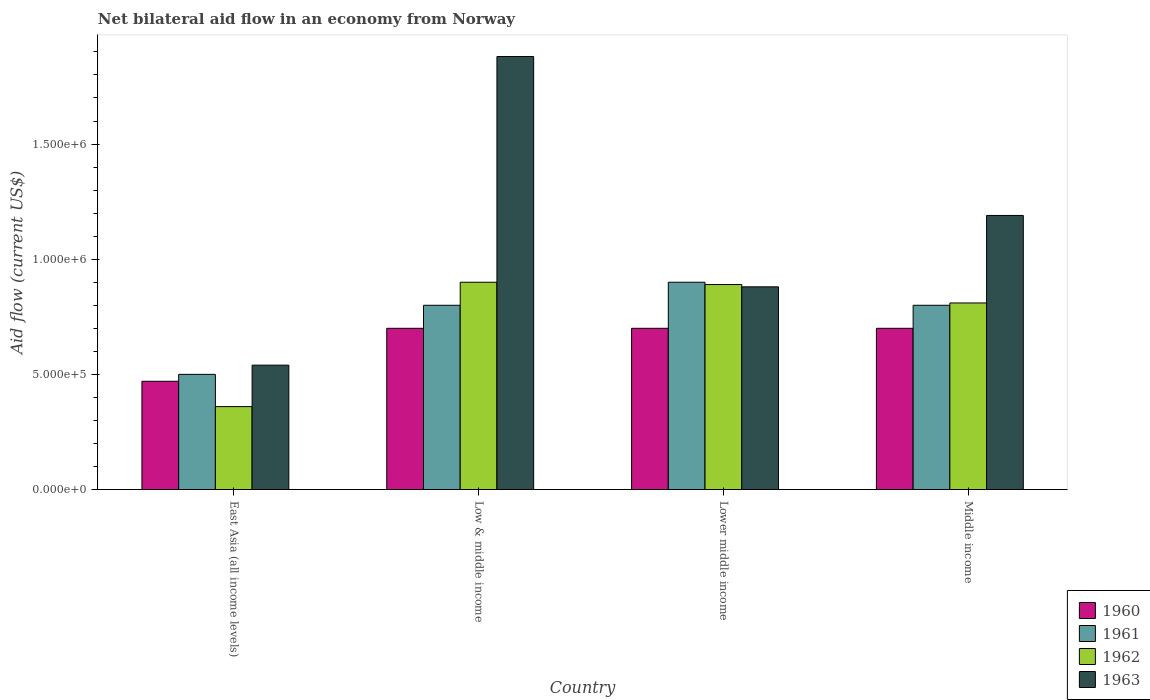How many different coloured bars are there?
Offer a terse response. 4. Are the number of bars on each tick of the X-axis equal?
Offer a terse response. Yes. How many bars are there on the 2nd tick from the left?
Your answer should be very brief. 4. What is the label of the 1st group of bars from the left?
Your answer should be compact. East Asia (all income levels). In how many cases, is the number of bars for a given country not equal to the number of legend labels?
Your response must be concise. 0. Across all countries, what is the maximum net bilateral aid flow in 1962?
Keep it short and to the point. 9.00e+05. In which country was the net bilateral aid flow in 1961 maximum?
Provide a succinct answer. Lower middle income. In which country was the net bilateral aid flow in 1962 minimum?
Offer a very short reply. East Asia (all income levels). What is the difference between the net bilateral aid flow in 1960 in East Asia (all income levels) and that in Middle income?
Ensure brevity in your answer.  -2.30e+05. What is the average net bilateral aid flow in 1960 per country?
Offer a very short reply. 6.42e+05. What is the ratio of the net bilateral aid flow in 1960 in Lower middle income to that in Middle income?
Offer a very short reply. 1. Is the net bilateral aid flow in 1961 in Low & middle income less than that in Lower middle income?
Offer a terse response. Yes. What is the difference between the highest and the second highest net bilateral aid flow in 1962?
Provide a short and direct response. 9.00e+04. Is it the case that in every country, the sum of the net bilateral aid flow in 1960 and net bilateral aid flow in 1963 is greater than the net bilateral aid flow in 1961?
Make the answer very short. Yes. Are all the bars in the graph horizontal?
Ensure brevity in your answer.  No. Are the values on the major ticks of Y-axis written in scientific E-notation?
Provide a short and direct response. Yes. Does the graph contain grids?
Offer a terse response. No. How many legend labels are there?
Provide a succinct answer. 4. What is the title of the graph?
Ensure brevity in your answer.  Net bilateral aid flow in an economy from Norway. Does "1985" appear as one of the legend labels in the graph?
Offer a very short reply. No. What is the label or title of the X-axis?
Your response must be concise. Country. What is the Aid flow (current US$) of 1963 in East Asia (all income levels)?
Provide a short and direct response. 5.40e+05. What is the Aid flow (current US$) in 1960 in Low & middle income?
Offer a very short reply. 7.00e+05. What is the Aid flow (current US$) of 1961 in Low & middle income?
Ensure brevity in your answer.  8.00e+05. What is the Aid flow (current US$) of 1963 in Low & middle income?
Ensure brevity in your answer.  1.88e+06. What is the Aid flow (current US$) of 1962 in Lower middle income?
Your answer should be compact. 8.90e+05. What is the Aid flow (current US$) in 1963 in Lower middle income?
Ensure brevity in your answer.  8.80e+05. What is the Aid flow (current US$) in 1960 in Middle income?
Make the answer very short. 7.00e+05. What is the Aid flow (current US$) in 1962 in Middle income?
Your answer should be compact. 8.10e+05. What is the Aid flow (current US$) in 1963 in Middle income?
Your response must be concise. 1.19e+06. Across all countries, what is the maximum Aid flow (current US$) in 1960?
Keep it short and to the point. 7.00e+05. Across all countries, what is the maximum Aid flow (current US$) in 1963?
Make the answer very short. 1.88e+06. Across all countries, what is the minimum Aid flow (current US$) of 1960?
Keep it short and to the point. 4.70e+05. Across all countries, what is the minimum Aid flow (current US$) of 1961?
Make the answer very short. 5.00e+05. Across all countries, what is the minimum Aid flow (current US$) in 1963?
Offer a terse response. 5.40e+05. What is the total Aid flow (current US$) of 1960 in the graph?
Make the answer very short. 2.57e+06. What is the total Aid flow (current US$) of 1962 in the graph?
Keep it short and to the point. 2.96e+06. What is the total Aid flow (current US$) of 1963 in the graph?
Offer a very short reply. 4.49e+06. What is the difference between the Aid flow (current US$) in 1961 in East Asia (all income levels) and that in Low & middle income?
Ensure brevity in your answer.  -3.00e+05. What is the difference between the Aid flow (current US$) of 1962 in East Asia (all income levels) and that in Low & middle income?
Offer a terse response. -5.40e+05. What is the difference between the Aid flow (current US$) of 1963 in East Asia (all income levels) and that in Low & middle income?
Keep it short and to the point. -1.34e+06. What is the difference between the Aid flow (current US$) in 1960 in East Asia (all income levels) and that in Lower middle income?
Ensure brevity in your answer.  -2.30e+05. What is the difference between the Aid flow (current US$) in 1961 in East Asia (all income levels) and that in Lower middle income?
Keep it short and to the point. -4.00e+05. What is the difference between the Aid flow (current US$) of 1962 in East Asia (all income levels) and that in Lower middle income?
Your response must be concise. -5.30e+05. What is the difference between the Aid flow (current US$) in 1960 in East Asia (all income levels) and that in Middle income?
Provide a succinct answer. -2.30e+05. What is the difference between the Aid flow (current US$) in 1962 in East Asia (all income levels) and that in Middle income?
Your response must be concise. -4.50e+05. What is the difference between the Aid flow (current US$) of 1963 in East Asia (all income levels) and that in Middle income?
Ensure brevity in your answer.  -6.50e+05. What is the difference between the Aid flow (current US$) in 1960 in Low & middle income and that in Lower middle income?
Your answer should be very brief. 0. What is the difference between the Aid flow (current US$) in 1961 in Low & middle income and that in Lower middle income?
Your response must be concise. -1.00e+05. What is the difference between the Aid flow (current US$) in 1962 in Low & middle income and that in Lower middle income?
Provide a succinct answer. 10000. What is the difference between the Aid flow (current US$) in 1963 in Low & middle income and that in Lower middle income?
Offer a terse response. 1.00e+06. What is the difference between the Aid flow (current US$) of 1963 in Low & middle income and that in Middle income?
Provide a short and direct response. 6.90e+05. What is the difference between the Aid flow (current US$) of 1960 in Lower middle income and that in Middle income?
Your response must be concise. 0. What is the difference between the Aid flow (current US$) of 1961 in Lower middle income and that in Middle income?
Your response must be concise. 1.00e+05. What is the difference between the Aid flow (current US$) in 1963 in Lower middle income and that in Middle income?
Ensure brevity in your answer.  -3.10e+05. What is the difference between the Aid flow (current US$) in 1960 in East Asia (all income levels) and the Aid flow (current US$) in 1961 in Low & middle income?
Offer a very short reply. -3.30e+05. What is the difference between the Aid flow (current US$) of 1960 in East Asia (all income levels) and the Aid flow (current US$) of 1962 in Low & middle income?
Provide a succinct answer. -4.30e+05. What is the difference between the Aid flow (current US$) of 1960 in East Asia (all income levels) and the Aid flow (current US$) of 1963 in Low & middle income?
Offer a terse response. -1.41e+06. What is the difference between the Aid flow (current US$) in 1961 in East Asia (all income levels) and the Aid flow (current US$) in 1962 in Low & middle income?
Keep it short and to the point. -4.00e+05. What is the difference between the Aid flow (current US$) in 1961 in East Asia (all income levels) and the Aid flow (current US$) in 1963 in Low & middle income?
Keep it short and to the point. -1.38e+06. What is the difference between the Aid flow (current US$) in 1962 in East Asia (all income levels) and the Aid flow (current US$) in 1963 in Low & middle income?
Make the answer very short. -1.52e+06. What is the difference between the Aid flow (current US$) of 1960 in East Asia (all income levels) and the Aid flow (current US$) of 1961 in Lower middle income?
Ensure brevity in your answer.  -4.30e+05. What is the difference between the Aid flow (current US$) of 1960 in East Asia (all income levels) and the Aid flow (current US$) of 1962 in Lower middle income?
Give a very brief answer. -4.20e+05. What is the difference between the Aid flow (current US$) in 1960 in East Asia (all income levels) and the Aid flow (current US$) in 1963 in Lower middle income?
Provide a short and direct response. -4.10e+05. What is the difference between the Aid flow (current US$) in 1961 in East Asia (all income levels) and the Aid flow (current US$) in 1962 in Lower middle income?
Give a very brief answer. -3.90e+05. What is the difference between the Aid flow (current US$) in 1961 in East Asia (all income levels) and the Aid flow (current US$) in 1963 in Lower middle income?
Offer a very short reply. -3.80e+05. What is the difference between the Aid flow (current US$) of 1962 in East Asia (all income levels) and the Aid flow (current US$) of 1963 in Lower middle income?
Your answer should be very brief. -5.20e+05. What is the difference between the Aid flow (current US$) in 1960 in East Asia (all income levels) and the Aid flow (current US$) in 1961 in Middle income?
Your answer should be very brief. -3.30e+05. What is the difference between the Aid flow (current US$) of 1960 in East Asia (all income levels) and the Aid flow (current US$) of 1962 in Middle income?
Provide a short and direct response. -3.40e+05. What is the difference between the Aid flow (current US$) in 1960 in East Asia (all income levels) and the Aid flow (current US$) in 1963 in Middle income?
Your answer should be very brief. -7.20e+05. What is the difference between the Aid flow (current US$) of 1961 in East Asia (all income levels) and the Aid flow (current US$) of 1962 in Middle income?
Your response must be concise. -3.10e+05. What is the difference between the Aid flow (current US$) in 1961 in East Asia (all income levels) and the Aid flow (current US$) in 1963 in Middle income?
Offer a very short reply. -6.90e+05. What is the difference between the Aid flow (current US$) in 1962 in East Asia (all income levels) and the Aid flow (current US$) in 1963 in Middle income?
Make the answer very short. -8.30e+05. What is the difference between the Aid flow (current US$) of 1960 in Low & middle income and the Aid flow (current US$) of 1961 in Lower middle income?
Your answer should be compact. -2.00e+05. What is the difference between the Aid flow (current US$) of 1960 in Low & middle income and the Aid flow (current US$) of 1962 in Lower middle income?
Your response must be concise. -1.90e+05. What is the difference between the Aid flow (current US$) of 1962 in Low & middle income and the Aid flow (current US$) of 1963 in Lower middle income?
Your answer should be very brief. 2.00e+04. What is the difference between the Aid flow (current US$) in 1960 in Low & middle income and the Aid flow (current US$) in 1962 in Middle income?
Ensure brevity in your answer.  -1.10e+05. What is the difference between the Aid flow (current US$) of 1960 in Low & middle income and the Aid flow (current US$) of 1963 in Middle income?
Offer a terse response. -4.90e+05. What is the difference between the Aid flow (current US$) of 1961 in Low & middle income and the Aid flow (current US$) of 1963 in Middle income?
Your response must be concise. -3.90e+05. What is the difference between the Aid flow (current US$) in 1962 in Low & middle income and the Aid flow (current US$) in 1963 in Middle income?
Provide a short and direct response. -2.90e+05. What is the difference between the Aid flow (current US$) in 1960 in Lower middle income and the Aid flow (current US$) in 1961 in Middle income?
Ensure brevity in your answer.  -1.00e+05. What is the difference between the Aid flow (current US$) of 1960 in Lower middle income and the Aid flow (current US$) of 1962 in Middle income?
Your answer should be compact. -1.10e+05. What is the difference between the Aid flow (current US$) in 1960 in Lower middle income and the Aid flow (current US$) in 1963 in Middle income?
Keep it short and to the point. -4.90e+05. What is the difference between the Aid flow (current US$) in 1961 in Lower middle income and the Aid flow (current US$) in 1963 in Middle income?
Keep it short and to the point. -2.90e+05. What is the average Aid flow (current US$) of 1960 per country?
Offer a very short reply. 6.42e+05. What is the average Aid flow (current US$) in 1961 per country?
Your response must be concise. 7.50e+05. What is the average Aid flow (current US$) in 1962 per country?
Keep it short and to the point. 7.40e+05. What is the average Aid flow (current US$) of 1963 per country?
Your answer should be very brief. 1.12e+06. What is the difference between the Aid flow (current US$) of 1960 and Aid flow (current US$) of 1961 in East Asia (all income levels)?
Ensure brevity in your answer.  -3.00e+04. What is the difference between the Aid flow (current US$) of 1960 and Aid flow (current US$) of 1962 in East Asia (all income levels)?
Give a very brief answer. 1.10e+05. What is the difference between the Aid flow (current US$) in 1961 and Aid flow (current US$) in 1963 in East Asia (all income levels)?
Offer a very short reply. -4.00e+04. What is the difference between the Aid flow (current US$) of 1960 and Aid flow (current US$) of 1961 in Low & middle income?
Keep it short and to the point. -1.00e+05. What is the difference between the Aid flow (current US$) of 1960 and Aid flow (current US$) of 1962 in Low & middle income?
Make the answer very short. -2.00e+05. What is the difference between the Aid flow (current US$) in 1960 and Aid flow (current US$) in 1963 in Low & middle income?
Give a very brief answer. -1.18e+06. What is the difference between the Aid flow (current US$) of 1961 and Aid flow (current US$) of 1963 in Low & middle income?
Offer a terse response. -1.08e+06. What is the difference between the Aid flow (current US$) in 1962 and Aid flow (current US$) in 1963 in Low & middle income?
Your response must be concise. -9.80e+05. What is the difference between the Aid flow (current US$) of 1960 and Aid flow (current US$) of 1962 in Lower middle income?
Your answer should be compact. -1.90e+05. What is the difference between the Aid flow (current US$) in 1961 and Aid flow (current US$) in 1962 in Lower middle income?
Provide a succinct answer. 10000. What is the difference between the Aid flow (current US$) in 1961 and Aid flow (current US$) in 1963 in Lower middle income?
Your answer should be very brief. 2.00e+04. What is the difference between the Aid flow (current US$) in 1962 and Aid flow (current US$) in 1963 in Lower middle income?
Provide a short and direct response. 10000. What is the difference between the Aid flow (current US$) of 1960 and Aid flow (current US$) of 1962 in Middle income?
Your response must be concise. -1.10e+05. What is the difference between the Aid flow (current US$) in 1960 and Aid flow (current US$) in 1963 in Middle income?
Provide a short and direct response. -4.90e+05. What is the difference between the Aid flow (current US$) in 1961 and Aid flow (current US$) in 1962 in Middle income?
Give a very brief answer. -10000. What is the difference between the Aid flow (current US$) of 1961 and Aid flow (current US$) of 1963 in Middle income?
Ensure brevity in your answer.  -3.90e+05. What is the difference between the Aid flow (current US$) in 1962 and Aid flow (current US$) in 1963 in Middle income?
Ensure brevity in your answer.  -3.80e+05. What is the ratio of the Aid flow (current US$) of 1960 in East Asia (all income levels) to that in Low & middle income?
Make the answer very short. 0.67. What is the ratio of the Aid flow (current US$) of 1961 in East Asia (all income levels) to that in Low & middle income?
Offer a very short reply. 0.62. What is the ratio of the Aid flow (current US$) in 1962 in East Asia (all income levels) to that in Low & middle income?
Offer a very short reply. 0.4. What is the ratio of the Aid flow (current US$) in 1963 in East Asia (all income levels) to that in Low & middle income?
Offer a terse response. 0.29. What is the ratio of the Aid flow (current US$) in 1960 in East Asia (all income levels) to that in Lower middle income?
Ensure brevity in your answer.  0.67. What is the ratio of the Aid flow (current US$) in 1961 in East Asia (all income levels) to that in Lower middle income?
Offer a terse response. 0.56. What is the ratio of the Aid flow (current US$) in 1962 in East Asia (all income levels) to that in Lower middle income?
Provide a short and direct response. 0.4. What is the ratio of the Aid flow (current US$) in 1963 in East Asia (all income levels) to that in Lower middle income?
Your answer should be compact. 0.61. What is the ratio of the Aid flow (current US$) in 1960 in East Asia (all income levels) to that in Middle income?
Your response must be concise. 0.67. What is the ratio of the Aid flow (current US$) in 1962 in East Asia (all income levels) to that in Middle income?
Provide a short and direct response. 0.44. What is the ratio of the Aid flow (current US$) in 1963 in East Asia (all income levels) to that in Middle income?
Offer a very short reply. 0.45. What is the ratio of the Aid flow (current US$) of 1960 in Low & middle income to that in Lower middle income?
Give a very brief answer. 1. What is the ratio of the Aid flow (current US$) in 1961 in Low & middle income to that in Lower middle income?
Make the answer very short. 0.89. What is the ratio of the Aid flow (current US$) in 1962 in Low & middle income to that in Lower middle income?
Make the answer very short. 1.01. What is the ratio of the Aid flow (current US$) in 1963 in Low & middle income to that in Lower middle income?
Your answer should be compact. 2.14. What is the ratio of the Aid flow (current US$) in 1961 in Low & middle income to that in Middle income?
Provide a succinct answer. 1. What is the ratio of the Aid flow (current US$) of 1962 in Low & middle income to that in Middle income?
Your answer should be very brief. 1.11. What is the ratio of the Aid flow (current US$) in 1963 in Low & middle income to that in Middle income?
Ensure brevity in your answer.  1.58. What is the ratio of the Aid flow (current US$) of 1962 in Lower middle income to that in Middle income?
Ensure brevity in your answer.  1.1. What is the ratio of the Aid flow (current US$) in 1963 in Lower middle income to that in Middle income?
Your response must be concise. 0.74. What is the difference between the highest and the second highest Aid flow (current US$) of 1960?
Offer a terse response. 0. What is the difference between the highest and the second highest Aid flow (current US$) in 1963?
Offer a terse response. 6.90e+05. What is the difference between the highest and the lowest Aid flow (current US$) in 1961?
Ensure brevity in your answer.  4.00e+05. What is the difference between the highest and the lowest Aid flow (current US$) in 1962?
Provide a short and direct response. 5.40e+05. What is the difference between the highest and the lowest Aid flow (current US$) in 1963?
Give a very brief answer. 1.34e+06. 